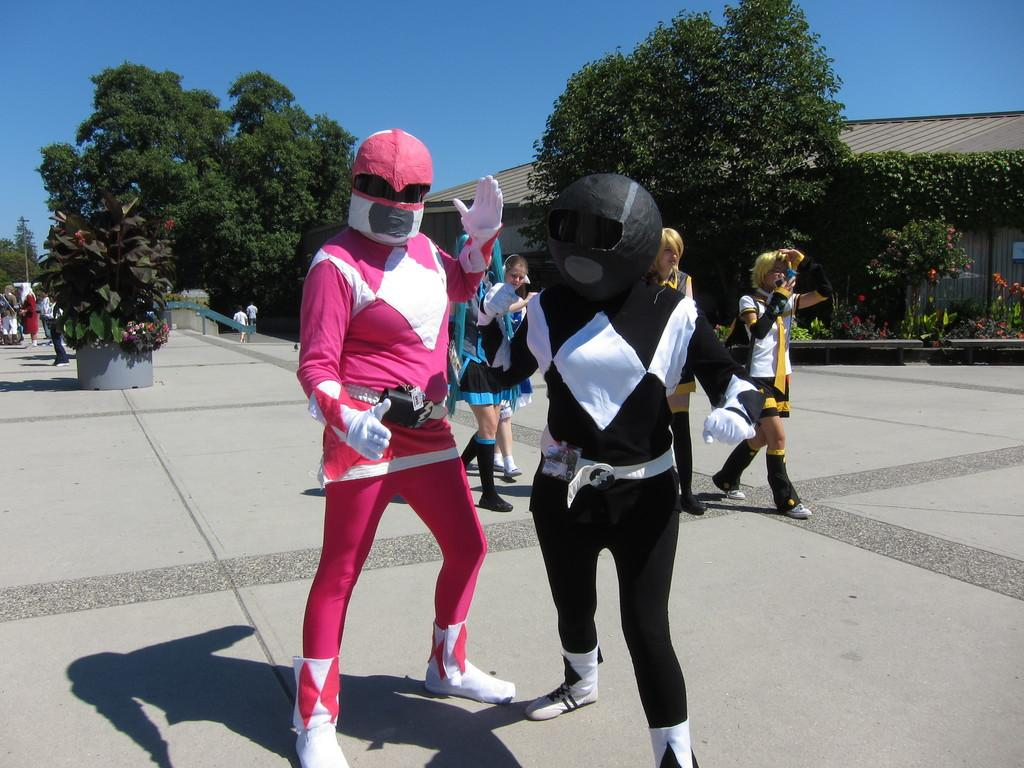What is happening on the road in the image? There is a group of people on the road in the image. What can be seen in the background of the image? There are trees, a house, and the sky visible in the background of the image. How many cats are sitting on the roof of the house in the image? There are no cats visible in the image; it only shows a group of people on the road and the background elements mentioned earlier. 